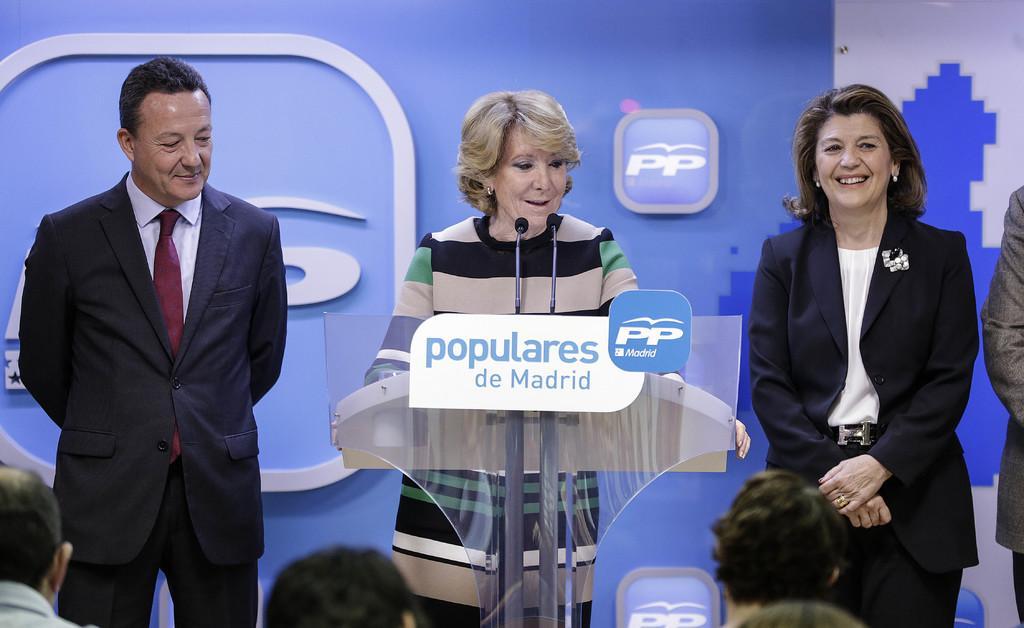How would you summarize this image in a sentence or two? This picture describes about group of people, in the middle of the image we can see a woman, she is standing in front of the podium, and we can see couple of microphones in front of her. 